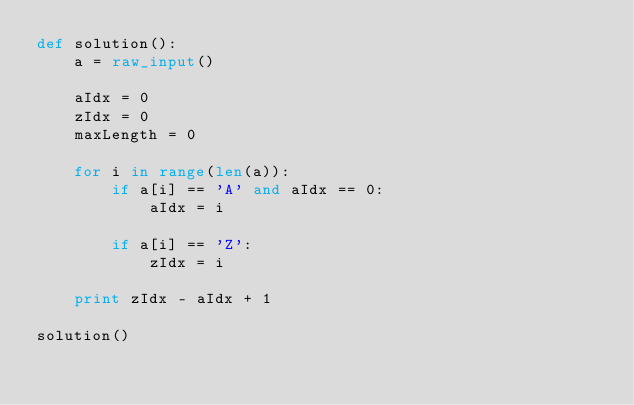Convert code to text. <code><loc_0><loc_0><loc_500><loc_500><_Python_>def solution():
	a = raw_input()
		
	aIdx = 0
	zIdx = 0
	maxLength = 0

	for i in range(len(a)):
		if a[i] == 'A' and aIdx == 0:
			aIdx = i
		
		if a[i] == 'Z':
			zIdx = i 

	print zIdx - aIdx + 1

solution()</code> 